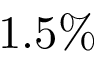Convert formula to latex. <formula><loc_0><loc_0><loc_500><loc_500>1 . 5 \%</formula> 